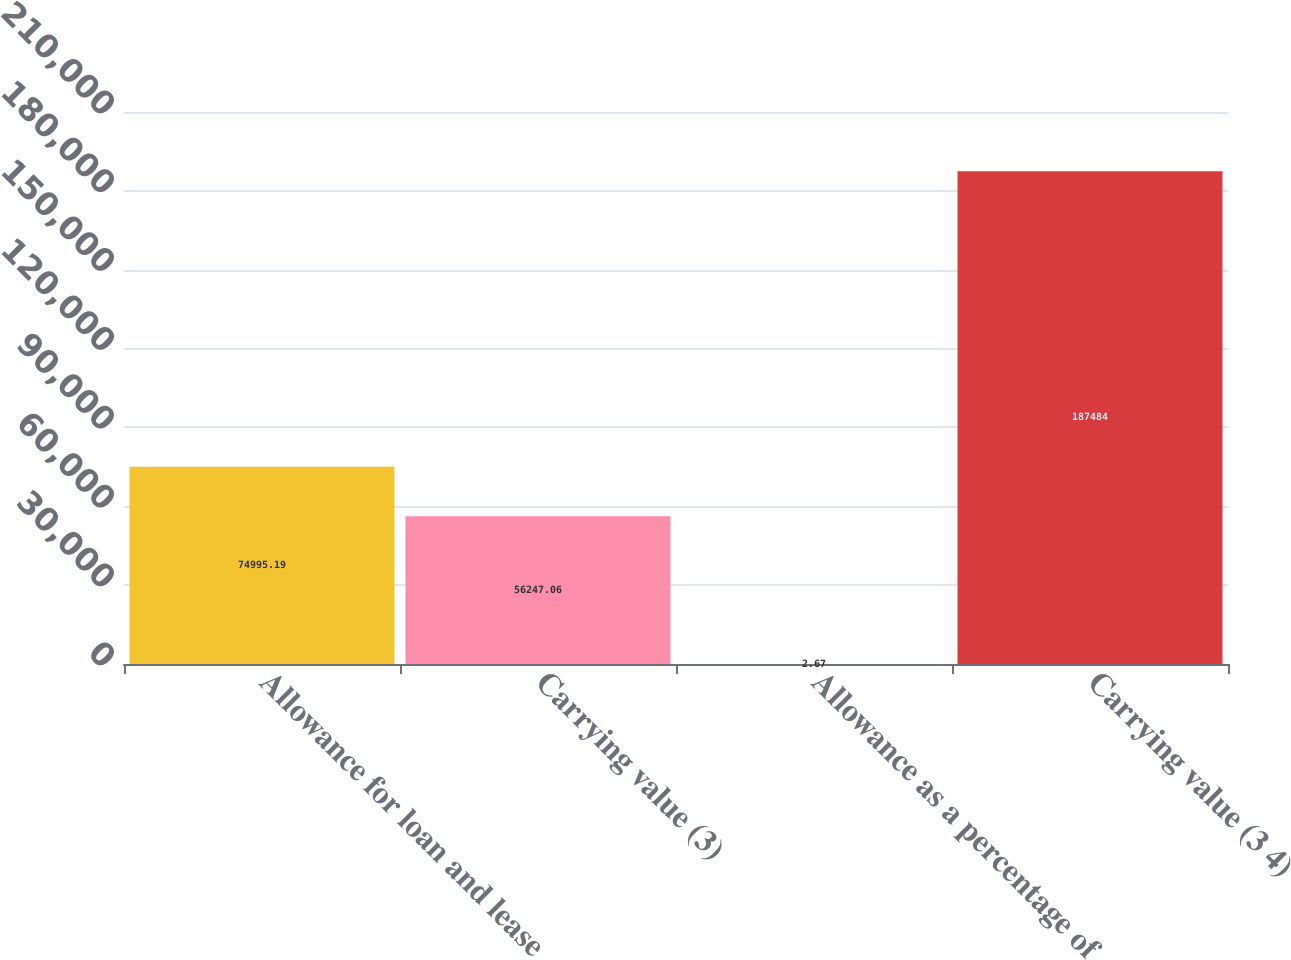Convert chart. <chart><loc_0><loc_0><loc_500><loc_500><bar_chart><fcel>Allowance for loan and lease<fcel>Carrying value (3)<fcel>Allowance as a percentage of<fcel>Carrying value (3 4)<nl><fcel>74995.2<fcel>56247.1<fcel>2.67<fcel>187484<nl></chart> 